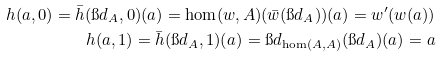<formula> <loc_0><loc_0><loc_500><loc_500>h ( a , 0 ) = \bar { h } ( \i d _ { A } , 0 ) ( a ) = \hom ( w , A ) ( \bar { w } ( \i d _ { A } ) ) ( a ) = w ^ { \prime } ( w ( a ) ) \\ h ( a , 1 ) = \bar { h } ( \i d _ { A } , 1 ) ( a ) = \i d _ { \hom ( A , A ) } ( \i d _ { A } ) ( a ) = a</formula> 